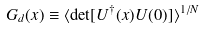<formula> <loc_0><loc_0><loc_500><loc_500>G _ { d } ( x ) \equiv \langle \det [ U ^ { \dagger } ( x ) U ( 0 ) ] \rangle ^ { 1 / N }</formula> 